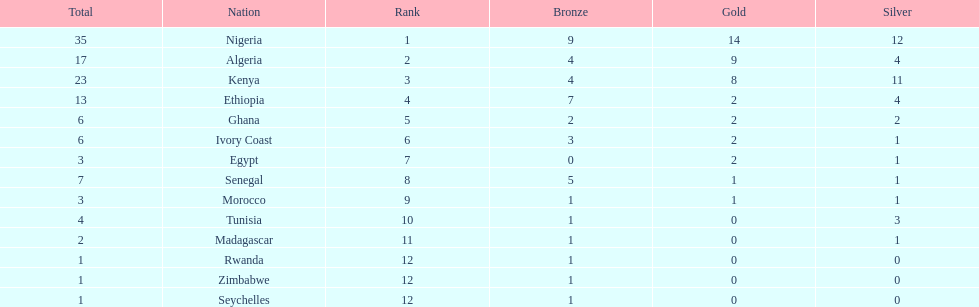What is the name of the only nation that did not earn any bronze medals? Egypt. 